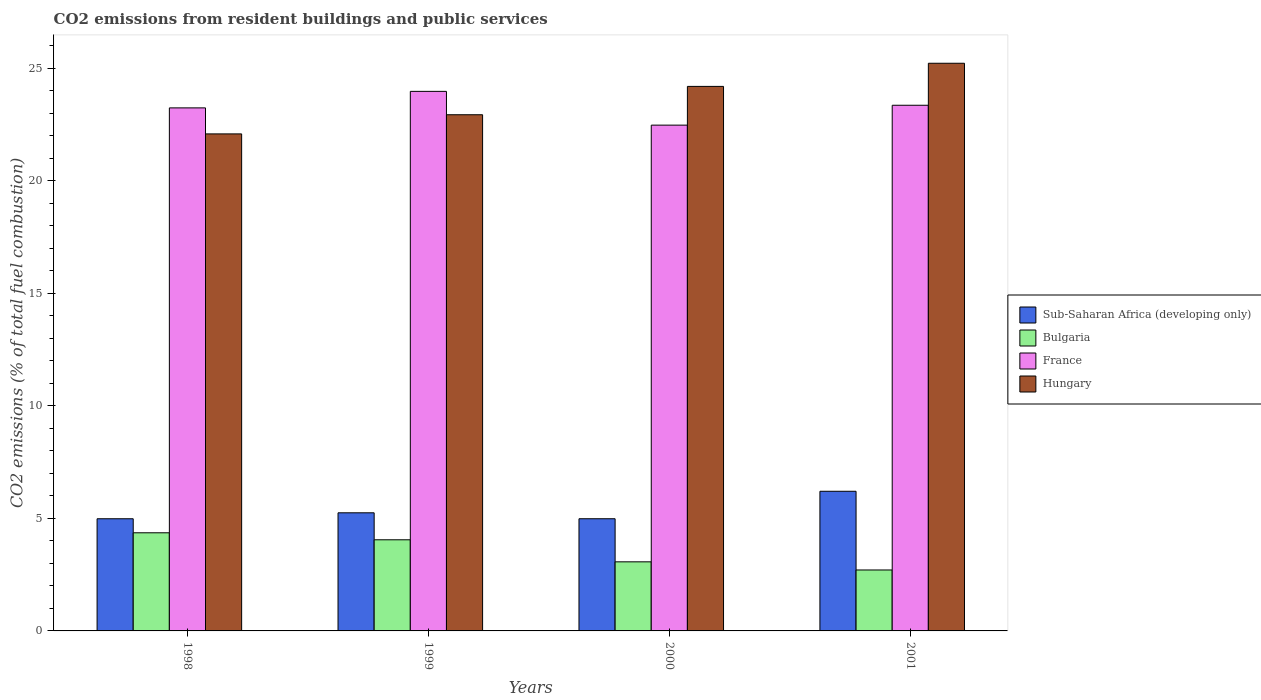How many different coloured bars are there?
Make the answer very short. 4. How many groups of bars are there?
Offer a terse response. 4. How many bars are there on the 2nd tick from the left?
Provide a succinct answer. 4. How many bars are there on the 4th tick from the right?
Ensure brevity in your answer.  4. What is the total CO2 emitted in Hungary in 2000?
Provide a succinct answer. 24.19. Across all years, what is the maximum total CO2 emitted in Hungary?
Offer a terse response. 25.22. Across all years, what is the minimum total CO2 emitted in France?
Provide a succinct answer. 22.47. In which year was the total CO2 emitted in Sub-Saharan Africa (developing only) minimum?
Offer a very short reply. 1998. What is the total total CO2 emitted in France in the graph?
Your answer should be very brief. 93.02. What is the difference between the total CO2 emitted in Hungary in 1998 and that in 1999?
Your answer should be compact. -0.85. What is the difference between the total CO2 emitted in Bulgaria in 2000 and the total CO2 emitted in Sub-Saharan Africa (developing only) in 1998?
Provide a short and direct response. -1.91. What is the average total CO2 emitted in Hungary per year?
Your answer should be very brief. 23.6. In the year 1999, what is the difference between the total CO2 emitted in Sub-Saharan Africa (developing only) and total CO2 emitted in Bulgaria?
Your answer should be compact. 1.2. In how many years, is the total CO2 emitted in Bulgaria greater than 23?
Ensure brevity in your answer.  0. What is the ratio of the total CO2 emitted in Hungary in 1999 to that in 2000?
Your response must be concise. 0.95. Is the total CO2 emitted in Bulgaria in 1999 less than that in 2001?
Provide a succinct answer. No. Is the difference between the total CO2 emitted in Sub-Saharan Africa (developing only) in 1998 and 2001 greater than the difference between the total CO2 emitted in Bulgaria in 1998 and 2001?
Ensure brevity in your answer.  No. What is the difference between the highest and the second highest total CO2 emitted in Bulgaria?
Provide a succinct answer. 0.31. What is the difference between the highest and the lowest total CO2 emitted in Sub-Saharan Africa (developing only)?
Offer a very short reply. 1.22. In how many years, is the total CO2 emitted in Bulgaria greater than the average total CO2 emitted in Bulgaria taken over all years?
Give a very brief answer. 2. Is the sum of the total CO2 emitted in Sub-Saharan Africa (developing only) in 2000 and 2001 greater than the maximum total CO2 emitted in Bulgaria across all years?
Ensure brevity in your answer.  Yes. Is it the case that in every year, the sum of the total CO2 emitted in Sub-Saharan Africa (developing only) and total CO2 emitted in France is greater than the sum of total CO2 emitted in Hungary and total CO2 emitted in Bulgaria?
Your answer should be very brief. Yes. What does the 4th bar from the left in 2001 represents?
Offer a terse response. Hungary. What does the 3rd bar from the right in 2001 represents?
Your answer should be very brief. Bulgaria. Is it the case that in every year, the sum of the total CO2 emitted in Bulgaria and total CO2 emitted in France is greater than the total CO2 emitted in Sub-Saharan Africa (developing only)?
Your answer should be very brief. Yes. How many years are there in the graph?
Keep it short and to the point. 4. Does the graph contain any zero values?
Your answer should be very brief. No. Where does the legend appear in the graph?
Keep it short and to the point. Center right. How many legend labels are there?
Provide a short and direct response. 4. What is the title of the graph?
Provide a succinct answer. CO2 emissions from resident buildings and public services. Does "Russian Federation" appear as one of the legend labels in the graph?
Give a very brief answer. No. What is the label or title of the X-axis?
Offer a very short reply. Years. What is the label or title of the Y-axis?
Keep it short and to the point. CO2 emissions (% of total fuel combustion). What is the CO2 emissions (% of total fuel combustion) of Sub-Saharan Africa (developing only) in 1998?
Your answer should be compact. 4.98. What is the CO2 emissions (% of total fuel combustion) of Bulgaria in 1998?
Offer a terse response. 4.36. What is the CO2 emissions (% of total fuel combustion) of France in 1998?
Provide a succinct answer. 23.23. What is the CO2 emissions (% of total fuel combustion) in Hungary in 1998?
Provide a short and direct response. 22.08. What is the CO2 emissions (% of total fuel combustion) in Sub-Saharan Africa (developing only) in 1999?
Ensure brevity in your answer.  5.25. What is the CO2 emissions (% of total fuel combustion) in Bulgaria in 1999?
Offer a very short reply. 4.05. What is the CO2 emissions (% of total fuel combustion) in France in 1999?
Provide a succinct answer. 23.97. What is the CO2 emissions (% of total fuel combustion) of Hungary in 1999?
Provide a succinct answer. 22.93. What is the CO2 emissions (% of total fuel combustion) of Sub-Saharan Africa (developing only) in 2000?
Offer a very short reply. 4.98. What is the CO2 emissions (% of total fuel combustion) of Bulgaria in 2000?
Make the answer very short. 3.07. What is the CO2 emissions (% of total fuel combustion) of France in 2000?
Offer a terse response. 22.47. What is the CO2 emissions (% of total fuel combustion) in Hungary in 2000?
Provide a short and direct response. 24.19. What is the CO2 emissions (% of total fuel combustion) of Sub-Saharan Africa (developing only) in 2001?
Offer a very short reply. 6.2. What is the CO2 emissions (% of total fuel combustion) in Bulgaria in 2001?
Your answer should be very brief. 2.71. What is the CO2 emissions (% of total fuel combustion) in France in 2001?
Your answer should be very brief. 23.35. What is the CO2 emissions (% of total fuel combustion) of Hungary in 2001?
Ensure brevity in your answer.  25.22. Across all years, what is the maximum CO2 emissions (% of total fuel combustion) in Sub-Saharan Africa (developing only)?
Make the answer very short. 6.2. Across all years, what is the maximum CO2 emissions (% of total fuel combustion) in Bulgaria?
Keep it short and to the point. 4.36. Across all years, what is the maximum CO2 emissions (% of total fuel combustion) of France?
Provide a succinct answer. 23.97. Across all years, what is the maximum CO2 emissions (% of total fuel combustion) of Hungary?
Provide a succinct answer. 25.22. Across all years, what is the minimum CO2 emissions (% of total fuel combustion) in Sub-Saharan Africa (developing only)?
Provide a short and direct response. 4.98. Across all years, what is the minimum CO2 emissions (% of total fuel combustion) in Bulgaria?
Provide a short and direct response. 2.71. Across all years, what is the minimum CO2 emissions (% of total fuel combustion) of France?
Offer a very short reply. 22.47. Across all years, what is the minimum CO2 emissions (% of total fuel combustion) of Hungary?
Offer a very short reply. 22.08. What is the total CO2 emissions (% of total fuel combustion) in Sub-Saharan Africa (developing only) in the graph?
Ensure brevity in your answer.  21.42. What is the total CO2 emissions (% of total fuel combustion) in Bulgaria in the graph?
Ensure brevity in your answer.  14.18. What is the total CO2 emissions (% of total fuel combustion) in France in the graph?
Your response must be concise. 93.02. What is the total CO2 emissions (% of total fuel combustion) of Hungary in the graph?
Offer a very short reply. 94.41. What is the difference between the CO2 emissions (% of total fuel combustion) in Sub-Saharan Africa (developing only) in 1998 and that in 1999?
Ensure brevity in your answer.  -0.26. What is the difference between the CO2 emissions (% of total fuel combustion) in Bulgaria in 1998 and that in 1999?
Give a very brief answer. 0.31. What is the difference between the CO2 emissions (% of total fuel combustion) in France in 1998 and that in 1999?
Provide a short and direct response. -0.73. What is the difference between the CO2 emissions (% of total fuel combustion) of Hungary in 1998 and that in 1999?
Provide a short and direct response. -0.85. What is the difference between the CO2 emissions (% of total fuel combustion) in Sub-Saharan Africa (developing only) in 1998 and that in 2000?
Provide a succinct answer. -0. What is the difference between the CO2 emissions (% of total fuel combustion) of Bulgaria in 1998 and that in 2000?
Ensure brevity in your answer.  1.29. What is the difference between the CO2 emissions (% of total fuel combustion) of France in 1998 and that in 2000?
Your answer should be compact. 0.77. What is the difference between the CO2 emissions (% of total fuel combustion) of Hungary in 1998 and that in 2000?
Offer a very short reply. -2.11. What is the difference between the CO2 emissions (% of total fuel combustion) in Sub-Saharan Africa (developing only) in 1998 and that in 2001?
Your answer should be very brief. -1.22. What is the difference between the CO2 emissions (% of total fuel combustion) of Bulgaria in 1998 and that in 2001?
Provide a short and direct response. 1.65. What is the difference between the CO2 emissions (% of total fuel combustion) of France in 1998 and that in 2001?
Your response must be concise. -0.12. What is the difference between the CO2 emissions (% of total fuel combustion) in Hungary in 1998 and that in 2001?
Provide a short and direct response. -3.14. What is the difference between the CO2 emissions (% of total fuel combustion) of Sub-Saharan Africa (developing only) in 1999 and that in 2000?
Provide a succinct answer. 0.26. What is the difference between the CO2 emissions (% of total fuel combustion) of Bulgaria in 1999 and that in 2000?
Keep it short and to the point. 0.98. What is the difference between the CO2 emissions (% of total fuel combustion) in France in 1999 and that in 2000?
Your answer should be very brief. 1.5. What is the difference between the CO2 emissions (% of total fuel combustion) of Hungary in 1999 and that in 2000?
Your answer should be very brief. -1.26. What is the difference between the CO2 emissions (% of total fuel combustion) in Sub-Saharan Africa (developing only) in 1999 and that in 2001?
Make the answer very short. -0.96. What is the difference between the CO2 emissions (% of total fuel combustion) in Bulgaria in 1999 and that in 2001?
Offer a terse response. 1.34. What is the difference between the CO2 emissions (% of total fuel combustion) in France in 1999 and that in 2001?
Give a very brief answer. 0.62. What is the difference between the CO2 emissions (% of total fuel combustion) in Hungary in 1999 and that in 2001?
Ensure brevity in your answer.  -2.29. What is the difference between the CO2 emissions (% of total fuel combustion) in Sub-Saharan Africa (developing only) in 2000 and that in 2001?
Give a very brief answer. -1.22. What is the difference between the CO2 emissions (% of total fuel combustion) of Bulgaria in 2000 and that in 2001?
Your answer should be compact. 0.36. What is the difference between the CO2 emissions (% of total fuel combustion) in France in 2000 and that in 2001?
Offer a terse response. -0.88. What is the difference between the CO2 emissions (% of total fuel combustion) of Hungary in 2000 and that in 2001?
Provide a short and direct response. -1.03. What is the difference between the CO2 emissions (% of total fuel combustion) of Sub-Saharan Africa (developing only) in 1998 and the CO2 emissions (% of total fuel combustion) of Bulgaria in 1999?
Offer a terse response. 0.93. What is the difference between the CO2 emissions (% of total fuel combustion) in Sub-Saharan Africa (developing only) in 1998 and the CO2 emissions (% of total fuel combustion) in France in 1999?
Offer a terse response. -18.99. What is the difference between the CO2 emissions (% of total fuel combustion) in Sub-Saharan Africa (developing only) in 1998 and the CO2 emissions (% of total fuel combustion) in Hungary in 1999?
Provide a succinct answer. -17.95. What is the difference between the CO2 emissions (% of total fuel combustion) in Bulgaria in 1998 and the CO2 emissions (% of total fuel combustion) in France in 1999?
Provide a succinct answer. -19.61. What is the difference between the CO2 emissions (% of total fuel combustion) in Bulgaria in 1998 and the CO2 emissions (% of total fuel combustion) in Hungary in 1999?
Offer a terse response. -18.57. What is the difference between the CO2 emissions (% of total fuel combustion) in France in 1998 and the CO2 emissions (% of total fuel combustion) in Hungary in 1999?
Provide a succinct answer. 0.3. What is the difference between the CO2 emissions (% of total fuel combustion) of Sub-Saharan Africa (developing only) in 1998 and the CO2 emissions (% of total fuel combustion) of Bulgaria in 2000?
Keep it short and to the point. 1.91. What is the difference between the CO2 emissions (% of total fuel combustion) of Sub-Saharan Africa (developing only) in 1998 and the CO2 emissions (% of total fuel combustion) of France in 2000?
Keep it short and to the point. -17.49. What is the difference between the CO2 emissions (% of total fuel combustion) of Sub-Saharan Africa (developing only) in 1998 and the CO2 emissions (% of total fuel combustion) of Hungary in 2000?
Your answer should be very brief. -19.21. What is the difference between the CO2 emissions (% of total fuel combustion) in Bulgaria in 1998 and the CO2 emissions (% of total fuel combustion) in France in 2000?
Provide a short and direct response. -18.11. What is the difference between the CO2 emissions (% of total fuel combustion) of Bulgaria in 1998 and the CO2 emissions (% of total fuel combustion) of Hungary in 2000?
Offer a terse response. -19.83. What is the difference between the CO2 emissions (% of total fuel combustion) of France in 1998 and the CO2 emissions (% of total fuel combustion) of Hungary in 2000?
Provide a succinct answer. -0.95. What is the difference between the CO2 emissions (% of total fuel combustion) in Sub-Saharan Africa (developing only) in 1998 and the CO2 emissions (% of total fuel combustion) in Bulgaria in 2001?
Keep it short and to the point. 2.27. What is the difference between the CO2 emissions (% of total fuel combustion) of Sub-Saharan Africa (developing only) in 1998 and the CO2 emissions (% of total fuel combustion) of France in 2001?
Your answer should be compact. -18.37. What is the difference between the CO2 emissions (% of total fuel combustion) in Sub-Saharan Africa (developing only) in 1998 and the CO2 emissions (% of total fuel combustion) in Hungary in 2001?
Offer a very short reply. -20.23. What is the difference between the CO2 emissions (% of total fuel combustion) of Bulgaria in 1998 and the CO2 emissions (% of total fuel combustion) of France in 2001?
Your response must be concise. -18.99. What is the difference between the CO2 emissions (% of total fuel combustion) of Bulgaria in 1998 and the CO2 emissions (% of total fuel combustion) of Hungary in 2001?
Provide a succinct answer. -20.86. What is the difference between the CO2 emissions (% of total fuel combustion) in France in 1998 and the CO2 emissions (% of total fuel combustion) in Hungary in 2001?
Your answer should be very brief. -1.98. What is the difference between the CO2 emissions (% of total fuel combustion) of Sub-Saharan Africa (developing only) in 1999 and the CO2 emissions (% of total fuel combustion) of Bulgaria in 2000?
Provide a short and direct response. 2.18. What is the difference between the CO2 emissions (% of total fuel combustion) in Sub-Saharan Africa (developing only) in 1999 and the CO2 emissions (% of total fuel combustion) in France in 2000?
Your answer should be compact. -17.22. What is the difference between the CO2 emissions (% of total fuel combustion) in Sub-Saharan Africa (developing only) in 1999 and the CO2 emissions (% of total fuel combustion) in Hungary in 2000?
Provide a short and direct response. -18.94. What is the difference between the CO2 emissions (% of total fuel combustion) in Bulgaria in 1999 and the CO2 emissions (% of total fuel combustion) in France in 2000?
Provide a short and direct response. -18.42. What is the difference between the CO2 emissions (% of total fuel combustion) in Bulgaria in 1999 and the CO2 emissions (% of total fuel combustion) in Hungary in 2000?
Ensure brevity in your answer.  -20.14. What is the difference between the CO2 emissions (% of total fuel combustion) of France in 1999 and the CO2 emissions (% of total fuel combustion) of Hungary in 2000?
Offer a very short reply. -0.22. What is the difference between the CO2 emissions (% of total fuel combustion) of Sub-Saharan Africa (developing only) in 1999 and the CO2 emissions (% of total fuel combustion) of Bulgaria in 2001?
Your answer should be compact. 2.54. What is the difference between the CO2 emissions (% of total fuel combustion) of Sub-Saharan Africa (developing only) in 1999 and the CO2 emissions (% of total fuel combustion) of France in 2001?
Make the answer very short. -18.1. What is the difference between the CO2 emissions (% of total fuel combustion) in Sub-Saharan Africa (developing only) in 1999 and the CO2 emissions (% of total fuel combustion) in Hungary in 2001?
Make the answer very short. -19.97. What is the difference between the CO2 emissions (% of total fuel combustion) in Bulgaria in 1999 and the CO2 emissions (% of total fuel combustion) in France in 2001?
Offer a terse response. -19.3. What is the difference between the CO2 emissions (% of total fuel combustion) of Bulgaria in 1999 and the CO2 emissions (% of total fuel combustion) of Hungary in 2001?
Give a very brief answer. -21.17. What is the difference between the CO2 emissions (% of total fuel combustion) of France in 1999 and the CO2 emissions (% of total fuel combustion) of Hungary in 2001?
Provide a succinct answer. -1.25. What is the difference between the CO2 emissions (% of total fuel combustion) in Sub-Saharan Africa (developing only) in 2000 and the CO2 emissions (% of total fuel combustion) in Bulgaria in 2001?
Offer a very short reply. 2.28. What is the difference between the CO2 emissions (% of total fuel combustion) of Sub-Saharan Africa (developing only) in 2000 and the CO2 emissions (% of total fuel combustion) of France in 2001?
Give a very brief answer. -18.37. What is the difference between the CO2 emissions (% of total fuel combustion) in Sub-Saharan Africa (developing only) in 2000 and the CO2 emissions (% of total fuel combustion) in Hungary in 2001?
Provide a succinct answer. -20.23. What is the difference between the CO2 emissions (% of total fuel combustion) of Bulgaria in 2000 and the CO2 emissions (% of total fuel combustion) of France in 2001?
Provide a succinct answer. -20.28. What is the difference between the CO2 emissions (% of total fuel combustion) in Bulgaria in 2000 and the CO2 emissions (% of total fuel combustion) in Hungary in 2001?
Your response must be concise. -22.15. What is the difference between the CO2 emissions (% of total fuel combustion) in France in 2000 and the CO2 emissions (% of total fuel combustion) in Hungary in 2001?
Your answer should be very brief. -2.75. What is the average CO2 emissions (% of total fuel combustion) in Sub-Saharan Africa (developing only) per year?
Your response must be concise. 5.35. What is the average CO2 emissions (% of total fuel combustion) of Bulgaria per year?
Offer a terse response. 3.55. What is the average CO2 emissions (% of total fuel combustion) of France per year?
Offer a terse response. 23.25. What is the average CO2 emissions (% of total fuel combustion) in Hungary per year?
Offer a very short reply. 23.6. In the year 1998, what is the difference between the CO2 emissions (% of total fuel combustion) in Sub-Saharan Africa (developing only) and CO2 emissions (% of total fuel combustion) in Bulgaria?
Ensure brevity in your answer.  0.62. In the year 1998, what is the difference between the CO2 emissions (% of total fuel combustion) of Sub-Saharan Africa (developing only) and CO2 emissions (% of total fuel combustion) of France?
Your answer should be compact. -18.25. In the year 1998, what is the difference between the CO2 emissions (% of total fuel combustion) of Sub-Saharan Africa (developing only) and CO2 emissions (% of total fuel combustion) of Hungary?
Offer a terse response. -17.1. In the year 1998, what is the difference between the CO2 emissions (% of total fuel combustion) of Bulgaria and CO2 emissions (% of total fuel combustion) of France?
Offer a terse response. -18.87. In the year 1998, what is the difference between the CO2 emissions (% of total fuel combustion) in Bulgaria and CO2 emissions (% of total fuel combustion) in Hungary?
Provide a short and direct response. -17.72. In the year 1998, what is the difference between the CO2 emissions (% of total fuel combustion) of France and CO2 emissions (% of total fuel combustion) of Hungary?
Keep it short and to the point. 1.16. In the year 1999, what is the difference between the CO2 emissions (% of total fuel combustion) of Sub-Saharan Africa (developing only) and CO2 emissions (% of total fuel combustion) of Bulgaria?
Provide a short and direct response. 1.2. In the year 1999, what is the difference between the CO2 emissions (% of total fuel combustion) in Sub-Saharan Africa (developing only) and CO2 emissions (% of total fuel combustion) in France?
Provide a succinct answer. -18.72. In the year 1999, what is the difference between the CO2 emissions (% of total fuel combustion) in Sub-Saharan Africa (developing only) and CO2 emissions (% of total fuel combustion) in Hungary?
Provide a short and direct response. -17.68. In the year 1999, what is the difference between the CO2 emissions (% of total fuel combustion) in Bulgaria and CO2 emissions (% of total fuel combustion) in France?
Ensure brevity in your answer.  -19.92. In the year 1999, what is the difference between the CO2 emissions (% of total fuel combustion) in Bulgaria and CO2 emissions (% of total fuel combustion) in Hungary?
Make the answer very short. -18.88. In the year 1999, what is the difference between the CO2 emissions (% of total fuel combustion) of France and CO2 emissions (% of total fuel combustion) of Hungary?
Ensure brevity in your answer.  1.04. In the year 2000, what is the difference between the CO2 emissions (% of total fuel combustion) in Sub-Saharan Africa (developing only) and CO2 emissions (% of total fuel combustion) in Bulgaria?
Keep it short and to the point. 1.91. In the year 2000, what is the difference between the CO2 emissions (% of total fuel combustion) in Sub-Saharan Africa (developing only) and CO2 emissions (% of total fuel combustion) in France?
Your answer should be very brief. -17.48. In the year 2000, what is the difference between the CO2 emissions (% of total fuel combustion) in Sub-Saharan Africa (developing only) and CO2 emissions (% of total fuel combustion) in Hungary?
Offer a very short reply. -19.21. In the year 2000, what is the difference between the CO2 emissions (% of total fuel combustion) of Bulgaria and CO2 emissions (% of total fuel combustion) of France?
Offer a very short reply. -19.4. In the year 2000, what is the difference between the CO2 emissions (% of total fuel combustion) in Bulgaria and CO2 emissions (% of total fuel combustion) in Hungary?
Ensure brevity in your answer.  -21.12. In the year 2000, what is the difference between the CO2 emissions (% of total fuel combustion) of France and CO2 emissions (% of total fuel combustion) of Hungary?
Keep it short and to the point. -1.72. In the year 2001, what is the difference between the CO2 emissions (% of total fuel combustion) of Sub-Saharan Africa (developing only) and CO2 emissions (% of total fuel combustion) of Bulgaria?
Your answer should be compact. 3.5. In the year 2001, what is the difference between the CO2 emissions (% of total fuel combustion) of Sub-Saharan Africa (developing only) and CO2 emissions (% of total fuel combustion) of France?
Ensure brevity in your answer.  -17.15. In the year 2001, what is the difference between the CO2 emissions (% of total fuel combustion) in Sub-Saharan Africa (developing only) and CO2 emissions (% of total fuel combustion) in Hungary?
Your answer should be very brief. -19.01. In the year 2001, what is the difference between the CO2 emissions (% of total fuel combustion) in Bulgaria and CO2 emissions (% of total fuel combustion) in France?
Make the answer very short. -20.64. In the year 2001, what is the difference between the CO2 emissions (% of total fuel combustion) in Bulgaria and CO2 emissions (% of total fuel combustion) in Hungary?
Your answer should be compact. -22.51. In the year 2001, what is the difference between the CO2 emissions (% of total fuel combustion) of France and CO2 emissions (% of total fuel combustion) of Hungary?
Keep it short and to the point. -1.87. What is the ratio of the CO2 emissions (% of total fuel combustion) in Sub-Saharan Africa (developing only) in 1998 to that in 1999?
Your answer should be very brief. 0.95. What is the ratio of the CO2 emissions (% of total fuel combustion) of Bulgaria in 1998 to that in 1999?
Provide a succinct answer. 1.08. What is the ratio of the CO2 emissions (% of total fuel combustion) in France in 1998 to that in 1999?
Provide a succinct answer. 0.97. What is the ratio of the CO2 emissions (% of total fuel combustion) in Hungary in 1998 to that in 1999?
Your answer should be very brief. 0.96. What is the ratio of the CO2 emissions (% of total fuel combustion) of Bulgaria in 1998 to that in 2000?
Give a very brief answer. 1.42. What is the ratio of the CO2 emissions (% of total fuel combustion) of France in 1998 to that in 2000?
Provide a short and direct response. 1.03. What is the ratio of the CO2 emissions (% of total fuel combustion) in Hungary in 1998 to that in 2000?
Provide a short and direct response. 0.91. What is the ratio of the CO2 emissions (% of total fuel combustion) in Sub-Saharan Africa (developing only) in 1998 to that in 2001?
Offer a terse response. 0.8. What is the ratio of the CO2 emissions (% of total fuel combustion) of Bulgaria in 1998 to that in 2001?
Your answer should be very brief. 1.61. What is the ratio of the CO2 emissions (% of total fuel combustion) of Hungary in 1998 to that in 2001?
Give a very brief answer. 0.88. What is the ratio of the CO2 emissions (% of total fuel combustion) of Sub-Saharan Africa (developing only) in 1999 to that in 2000?
Offer a terse response. 1.05. What is the ratio of the CO2 emissions (% of total fuel combustion) in Bulgaria in 1999 to that in 2000?
Provide a succinct answer. 1.32. What is the ratio of the CO2 emissions (% of total fuel combustion) in France in 1999 to that in 2000?
Give a very brief answer. 1.07. What is the ratio of the CO2 emissions (% of total fuel combustion) of Hungary in 1999 to that in 2000?
Ensure brevity in your answer.  0.95. What is the ratio of the CO2 emissions (% of total fuel combustion) of Sub-Saharan Africa (developing only) in 1999 to that in 2001?
Provide a short and direct response. 0.85. What is the ratio of the CO2 emissions (% of total fuel combustion) of Bulgaria in 1999 to that in 2001?
Offer a very short reply. 1.5. What is the ratio of the CO2 emissions (% of total fuel combustion) in France in 1999 to that in 2001?
Keep it short and to the point. 1.03. What is the ratio of the CO2 emissions (% of total fuel combustion) of Hungary in 1999 to that in 2001?
Your answer should be compact. 0.91. What is the ratio of the CO2 emissions (% of total fuel combustion) of Sub-Saharan Africa (developing only) in 2000 to that in 2001?
Offer a terse response. 0.8. What is the ratio of the CO2 emissions (% of total fuel combustion) of Bulgaria in 2000 to that in 2001?
Provide a short and direct response. 1.13. What is the ratio of the CO2 emissions (% of total fuel combustion) in France in 2000 to that in 2001?
Ensure brevity in your answer.  0.96. What is the ratio of the CO2 emissions (% of total fuel combustion) of Hungary in 2000 to that in 2001?
Give a very brief answer. 0.96. What is the difference between the highest and the second highest CO2 emissions (% of total fuel combustion) of Sub-Saharan Africa (developing only)?
Provide a succinct answer. 0.96. What is the difference between the highest and the second highest CO2 emissions (% of total fuel combustion) of Bulgaria?
Offer a very short reply. 0.31. What is the difference between the highest and the second highest CO2 emissions (% of total fuel combustion) of France?
Your response must be concise. 0.62. What is the difference between the highest and the second highest CO2 emissions (% of total fuel combustion) of Hungary?
Your answer should be compact. 1.03. What is the difference between the highest and the lowest CO2 emissions (% of total fuel combustion) in Sub-Saharan Africa (developing only)?
Give a very brief answer. 1.22. What is the difference between the highest and the lowest CO2 emissions (% of total fuel combustion) of Bulgaria?
Offer a terse response. 1.65. What is the difference between the highest and the lowest CO2 emissions (% of total fuel combustion) of France?
Keep it short and to the point. 1.5. What is the difference between the highest and the lowest CO2 emissions (% of total fuel combustion) of Hungary?
Your answer should be compact. 3.14. 